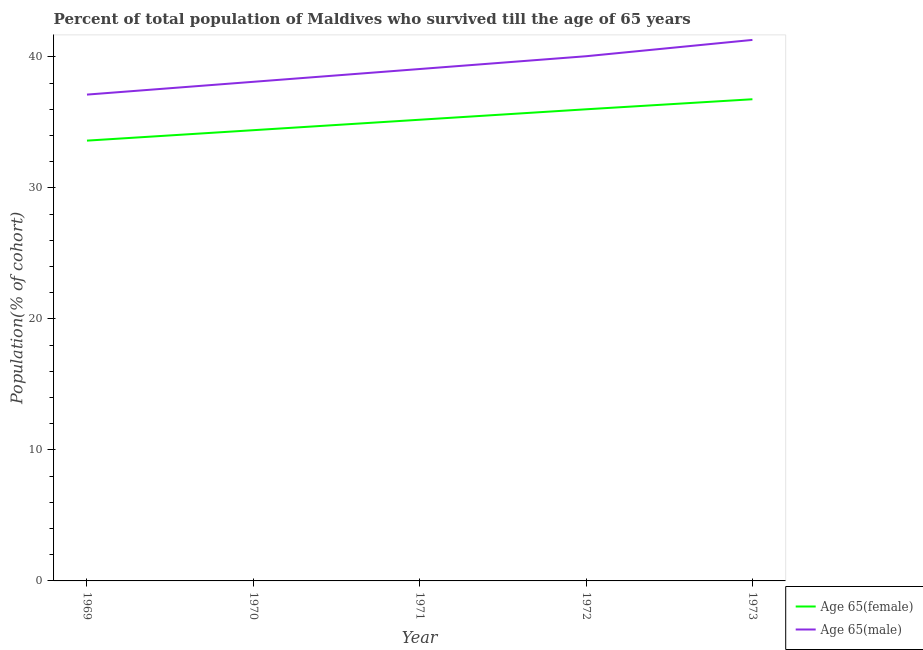Does the line corresponding to percentage of male population who survived till age of 65 intersect with the line corresponding to percentage of female population who survived till age of 65?
Give a very brief answer. No. Is the number of lines equal to the number of legend labels?
Your answer should be very brief. Yes. What is the percentage of female population who survived till age of 65 in 1973?
Offer a terse response. 36.77. Across all years, what is the maximum percentage of male population who survived till age of 65?
Keep it short and to the point. 41.3. Across all years, what is the minimum percentage of male population who survived till age of 65?
Your answer should be compact. 37.13. In which year was the percentage of female population who survived till age of 65 minimum?
Provide a short and direct response. 1969. What is the total percentage of female population who survived till age of 65 in the graph?
Keep it short and to the point. 176. What is the difference between the percentage of female population who survived till age of 65 in 1969 and that in 1970?
Your answer should be compact. -0.8. What is the difference between the percentage of male population who survived till age of 65 in 1971 and the percentage of female population who survived till age of 65 in 1970?
Ensure brevity in your answer.  4.67. What is the average percentage of female population who survived till age of 65 per year?
Your response must be concise. 35.2. In the year 1973, what is the difference between the percentage of male population who survived till age of 65 and percentage of female population who survived till age of 65?
Provide a short and direct response. 4.53. In how many years, is the percentage of male population who survived till age of 65 greater than 30 %?
Your response must be concise. 5. What is the ratio of the percentage of male population who survived till age of 65 in 1970 to that in 1971?
Provide a short and direct response. 0.98. What is the difference between the highest and the second highest percentage of female population who survived till age of 65?
Offer a very short reply. 0.77. What is the difference between the highest and the lowest percentage of female population who survived till age of 65?
Give a very brief answer. 3.16. Does the percentage of female population who survived till age of 65 monotonically increase over the years?
Offer a very short reply. Yes. Is the percentage of female population who survived till age of 65 strictly less than the percentage of male population who survived till age of 65 over the years?
Provide a succinct answer. Yes. How many lines are there?
Keep it short and to the point. 2. Are the values on the major ticks of Y-axis written in scientific E-notation?
Your answer should be very brief. No. Does the graph contain grids?
Make the answer very short. No. Where does the legend appear in the graph?
Offer a terse response. Bottom right. How are the legend labels stacked?
Give a very brief answer. Vertical. What is the title of the graph?
Give a very brief answer. Percent of total population of Maldives who survived till the age of 65 years. Does "Males" appear as one of the legend labels in the graph?
Keep it short and to the point. No. What is the label or title of the Y-axis?
Give a very brief answer. Population(% of cohort). What is the Population(% of cohort) of Age 65(female) in 1969?
Your response must be concise. 33.61. What is the Population(% of cohort) in Age 65(male) in 1969?
Keep it short and to the point. 37.13. What is the Population(% of cohort) in Age 65(female) in 1970?
Your answer should be compact. 34.41. What is the Population(% of cohort) of Age 65(male) in 1970?
Provide a succinct answer. 38.1. What is the Population(% of cohort) in Age 65(female) in 1971?
Offer a terse response. 35.21. What is the Population(% of cohort) of Age 65(male) in 1971?
Your answer should be compact. 39.08. What is the Population(% of cohort) of Age 65(female) in 1972?
Provide a short and direct response. 36. What is the Population(% of cohort) of Age 65(male) in 1972?
Give a very brief answer. 40.05. What is the Population(% of cohort) in Age 65(female) in 1973?
Provide a succinct answer. 36.77. What is the Population(% of cohort) in Age 65(male) in 1973?
Provide a succinct answer. 41.3. Across all years, what is the maximum Population(% of cohort) of Age 65(female)?
Offer a very short reply. 36.77. Across all years, what is the maximum Population(% of cohort) in Age 65(male)?
Your answer should be compact. 41.3. Across all years, what is the minimum Population(% of cohort) in Age 65(female)?
Offer a very short reply. 33.61. Across all years, what is the minimum Population(% of cohort) of Age 65(male)?
Provide a succinct answer. 37.13. What is the total Population(% of cohort) of Age 65(female) in the graph?
Your answer should be compact. 176. What is the total Population(% of cohort) in Age 65(male) in the graph?
Offer a terse response. 195.66. What is the difference between the Population(% of cohort) in Age 65(female) in 1969 and that in 1970?
Keep it short and to the point. -0.8. What is the difference between the Population(% of cohort) in Age 65(male) in 1969 and that in 1970?
Keep it short and to the point. -0.98. What is the difference between the Population(% of cohort) in Age 65(female) in 1969 and that in 1971?
Your answer should be compact. -1.59. What is the difference between the Population(% of cohort) of Age 65(male) in 1969 and that in 1971?
Make the answer very short. -1.95. What is the difference between the Population(% of cohort) in Age 65(female) in 1969 and that in 1972?
Your answer should be compact. -2.39. What is the difference between the Population(% of cohort) of Age 65(male) in 1969 and that in 1972?
Your response must be concise. -2.93. What is the difference between the Population(% of cohort) of Age 65(female) in 1969 and that in 1973?
Your response must be concise. -3.16. What is the difference between the Population(% of cohort) in Age 65(male) in 1969 and that in 1973?
Offer a very short reply. -4.17. What is the difference between the Population(% of cohort) of Age 65(female) in 1970 and that in 1971?
Your answer should be very brief. -0.8. What is the difference between the Population(% of cohort) in Age 65(male) in 1970 and that in 1971?
Keep it short and to the point. -0.98. What is the difference between the Population(% of cohort) of Age 65(female) in 1970 and that in 1972?
Provide a succinct answer. -1.59. What is the difference between the Population(% of cohort) in Age 65(male) in 1970 and that in 1972?
Keep it short and to the point. -1.95. What is the difference between the Population(% of cohort) in Age 65(female) in 1970 and that in 1973?
Offer a terse response. -2.36. What is the difference between the Population(% of cohort) in Age 65(male) in 1970 and that in 1973?
Provide a succinct answer. -3.2. What is the difference between the Population(% of cohort) in Age 65(female) in 1971 and that in 1972?
Ensure brevity in your answer.  -0.8. What is the difference between the Population(% of cohort) in Age 65(male) in 1971 and that in 1972?
Ensure brevity in your answer.  -0.98. What is the difference between the Population(% of cohort) of Age 65(female) in 1971 and that in 1973?
Your answer should be compact. -1.56. What is the difference between the Population(% of cohort) of Age 65(male) in 1971 and that in 1973?
Ensure brevity in your answer.  -2.22. What is the difference between the Population(% of cohort) of Age 65(female) in 1972 and that in 1973?
Make the answer very short. -0.77. What is the difference between the Population(% of cohort) in Age 65(male) in 1972 and that in 1973?
Provide a succinct answer. -1.25. What is the difference between the Population(% of cohort) in Age 65(female) in 1969 and the Population(% of cohort) in Age 65(male) in 1970?
Your response must be concise. -4.49. What is the difference between the Population(% of cohort) in Age 65(female) in 1969 and the Population(% of cohort) in Age 65(male) in 1971?
Offer a terse response. -5.47. What is the difference between the Population(% of cohort) of Age 65(female) in 1969 and the Population(% of cohort) of Age 65(male) in 1972?
Your answer should be compact. -6.44. What is the difference between the Population(% of cohort) in Age 65(female) in 1969 and the Population(% of cohort) in Age 65(male) in 1973?
Your answer should be very brief. -7.69. What is the difference between the Population(% of cohort) of Age 65(female) in 1970 and the Population(% of cohort) of Age 65(male) in 1971?
Provide a short and direct response. -4.67. What is the difference between the Population(% of cohort) in Age 65(female) in 1970 and the Population(% of cohort) in Age 65(male) in 1972?
Your answer should be very brief. -5.65. What is the difference between the Population(% of cohort) in Age 65(female) in 1970 and the Population(% of cohort) in Age 65(male) in 1973?
Keep it short and to the point. -6.89. What is the difference between the Population(% of cohort) in Age 65(female) in 1971 and the Population(% of cohort) in Age 65(male) in 1972?
Ensure brevity in your answer.  -4.85. What is the difference between the Population(% of cohort) in Age 65(female) in 1971 and the Population(% of cohort) in Age 65(male) in 1973?
Offer a terse response. -6.09. What is the difference between the Population(% of cohort) in Age 65(female) in 1972 and the Population(% of cohort) in Age 65(male) in 1973?
Ensure brevity in your answer.  -5.3. What is the average Population(% of cohort) in Age 65(female) per year?
Your answer should be very brief. 35.2. What is the average Population(% of cohort) in Age 65(male) per year?
Your answer should be very brief. 39.13. In the year 1969, what is the difference between the Population(% of cohort) of Age 65(female) and Population(% of cohort) of Age 65(male)?
Keep it short and to the point. -3.51. In the year 1970, what is the difference between the Population(% of cohort) of Age 65(female) and Population(% of cohort) of Age 65(male)?
Provide a succinct answer. -3.69. In the year 1971, what is the difference between the Population(% of cohort) in Age 65(female) and Population(% of cohort) in Age 65(male)?
Your response must be concise. -3.87. In the year 1972, what is the difference between the Population(% of cohort) in Age 65(female) and Population(% of cohort) in Age 65(male)?
Offer a very short reply. -4.05. In the year 1973, what is the difference between the Population(% of cohort) of Age 65(female) and Population(% of cohort) of Age 65(male)?
Provide a succinct answer. -4.53. What is the ratio of the Population(% of cohort) of Age 65(female) in 1969 to that in 1970?
Your answer should be very brief. 0.98. What is the ratio of the Population(% of cohort) in Age 65(male) in 1969 to that in 1970?
Your answer should be very brief. 0.97. What is the ratio of the Population(% of cohort) of Age 65(female) in 1969 to that in 1971?
Your response must be concise. 0.95. What is the ratio of the Population(% of cohort) of Age 65(male) in 1969 to that in 1971?
Provide a succinct answer. 0.95. What is the ratio of the Population(% of cohort) of Age 65(female) in 1969 to that in 1972?
Keep it short and to the point. 0.93. What is the ratio of the Population(% of cohort) in Age 65(male) in 1969 to that in 1972?
Your response must be concise. 0.93. What is the ratio of the Population(% of cohort) of Age 65(female) in 1969 to that in 1973?
Your answer should be compact. 0.91. What is the ratio of the Population(% of cohort) in Age 65(male) in 1969 to that in 1973?
Your answer should be compact. 0.9. What is the ratio of the Population(% of cohort) of Age 65(female) in 1970 to that in 1971?
Ensure brevity in your answer.  0.98. What is the ratio of the Population(% of cohort) of Age 65(male) in 1970 to that in 1971?
Offer a terse response. 0.97. What is the ratio of the Population(% of cohort) in Age 65(female) in 1970 to that in 1972?
Your answer should be compact. 0.96. What is the ratio of the Population(% of cohort) of Age 65(male) in 1970 to that in 1972?
Ensure brevity in your answer.  0.95. What is the ratio of the Population(% of cohort) of Age 65(female) in 1970 to that in 1973?
Provide a succinct answer. 0.94. What is the ratio of the Population(% of cohort) of Age 65(male) in 1970 to that in 1973?
Your response must be concise. 0.92. What is the ratio of the Population(% of cohort) in Age 65(female) in 1971 to that in 1972?
Your answer should be very brief. 0.98. What is the ratio of the Population(% of cohort) of Age 65(male) in 1971 to that in 1972?
Your answer should be very brief. 0.98. What is the ratio of the Population(% of cohort) in Age 65(female) in 1971 to that in 1973?
Provide a succinct answer. 0.96. What is the ratio of the Population(% of cohort) of Age 65(male) in 1971 to that in 1973?
Ensure brevity in your answer.  0.95. What is the ratio of the Population(% of cohort) of Age 65(female) in 1972 to that in 1973?
Ensure brevity in your answer.  0.98. What is the ratio of the Population(% of cohort) of Age 65(male) in 1972 to that in 1973?
Ensure brevity in your answer.  0.97. What is the difference between the highest and the second highest Population(% of cohort) in Age 65(female)?
Your answer should be compact. 0.77. What is the difference between the highest and the second highest Population(% of cohort) in Age 65(male)?
Give a very brief answer. 1.25. What is the difference between the highest and the lowest Population(% of cohort) of Age 65(female)?
Ensure brevity in your answer.  3.16. What is the difference between the highest and the lowest Population(% of cohort) in Age 65(male)?
Your answer should be very brief. 4.17. 